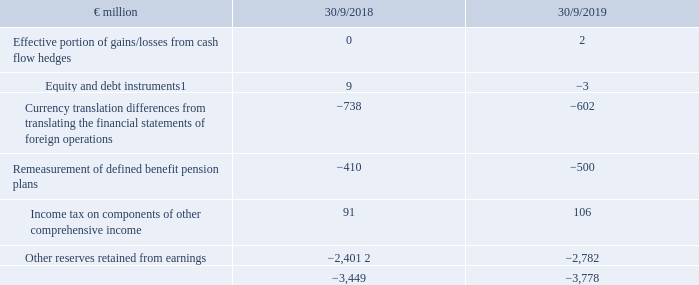Capital reserve and reserves retained from earnings
Prior to the effective date of the reclassification and demerger of CECONOMY AG on 12 July 2017, METRO AG was not yet a group within the meaning of IFRS 10. Accordingly, combined financial statements of METRO Wholesale & Food Specialist GROUP (hereinafter: MWFS GROUP) were prepared for the IPO prospectus of METRO AG. Equity in the combined financial statements was the residual amount from the combined assets and liabilities of MWFS GROUP. Following the demerger, METRO became an independent group with METRO AG as the listed parent company. Therefore, the equity in the consolidated financial statements is subdivided according to legal requirements. The subscribed capital of €363 million and the capital reserve of €6,118 million were recognised at the carrying amounts from the METRO AG Annual Financial Statements as of 30 September 2017. For this purpose, a transfer was made from the equity item net assets, recognised as of 1 October 2016, attributable to the former METRO GROUP of the combined financial statements of MWFS GROUP. The remaining negative amount of this equity item was reclassified to reserves retained from earnings. It cannot be traced back to a history of loss.
Reserves retained from earnings can be broken down as follows:
1 Previous year: gains/losses on remeasuring financial instruments in the category ‘available for sale’.
2 Adjustment of previous year according to explanation in notes.
What did the amount of equity and debt instruments in the previous year relate to? Gains/losses on remeasuring financial instruments in the category ‘available for sale’. What was the amount of other reserves retained from earnings in FY2018 adjusted for? Adjustment of previous year according to explanation in notes. In which years were the reserves retained from earnings calculated in? 2018, 2019. In which year was the Income tax on components of other comprehensive income larger? 106>91
Answer: 2019. What was the change in the Income tax on components of other comprehensive income in FY2019 from FY2018?
Answer scale should be: million. 106-91
Answer: 15. What was the percentage change in the Income tax on components of other comprehensive income in FY2019 from FY2018?
Answer scale should be: percent. (106-91)/91
Answer: 16.48. 